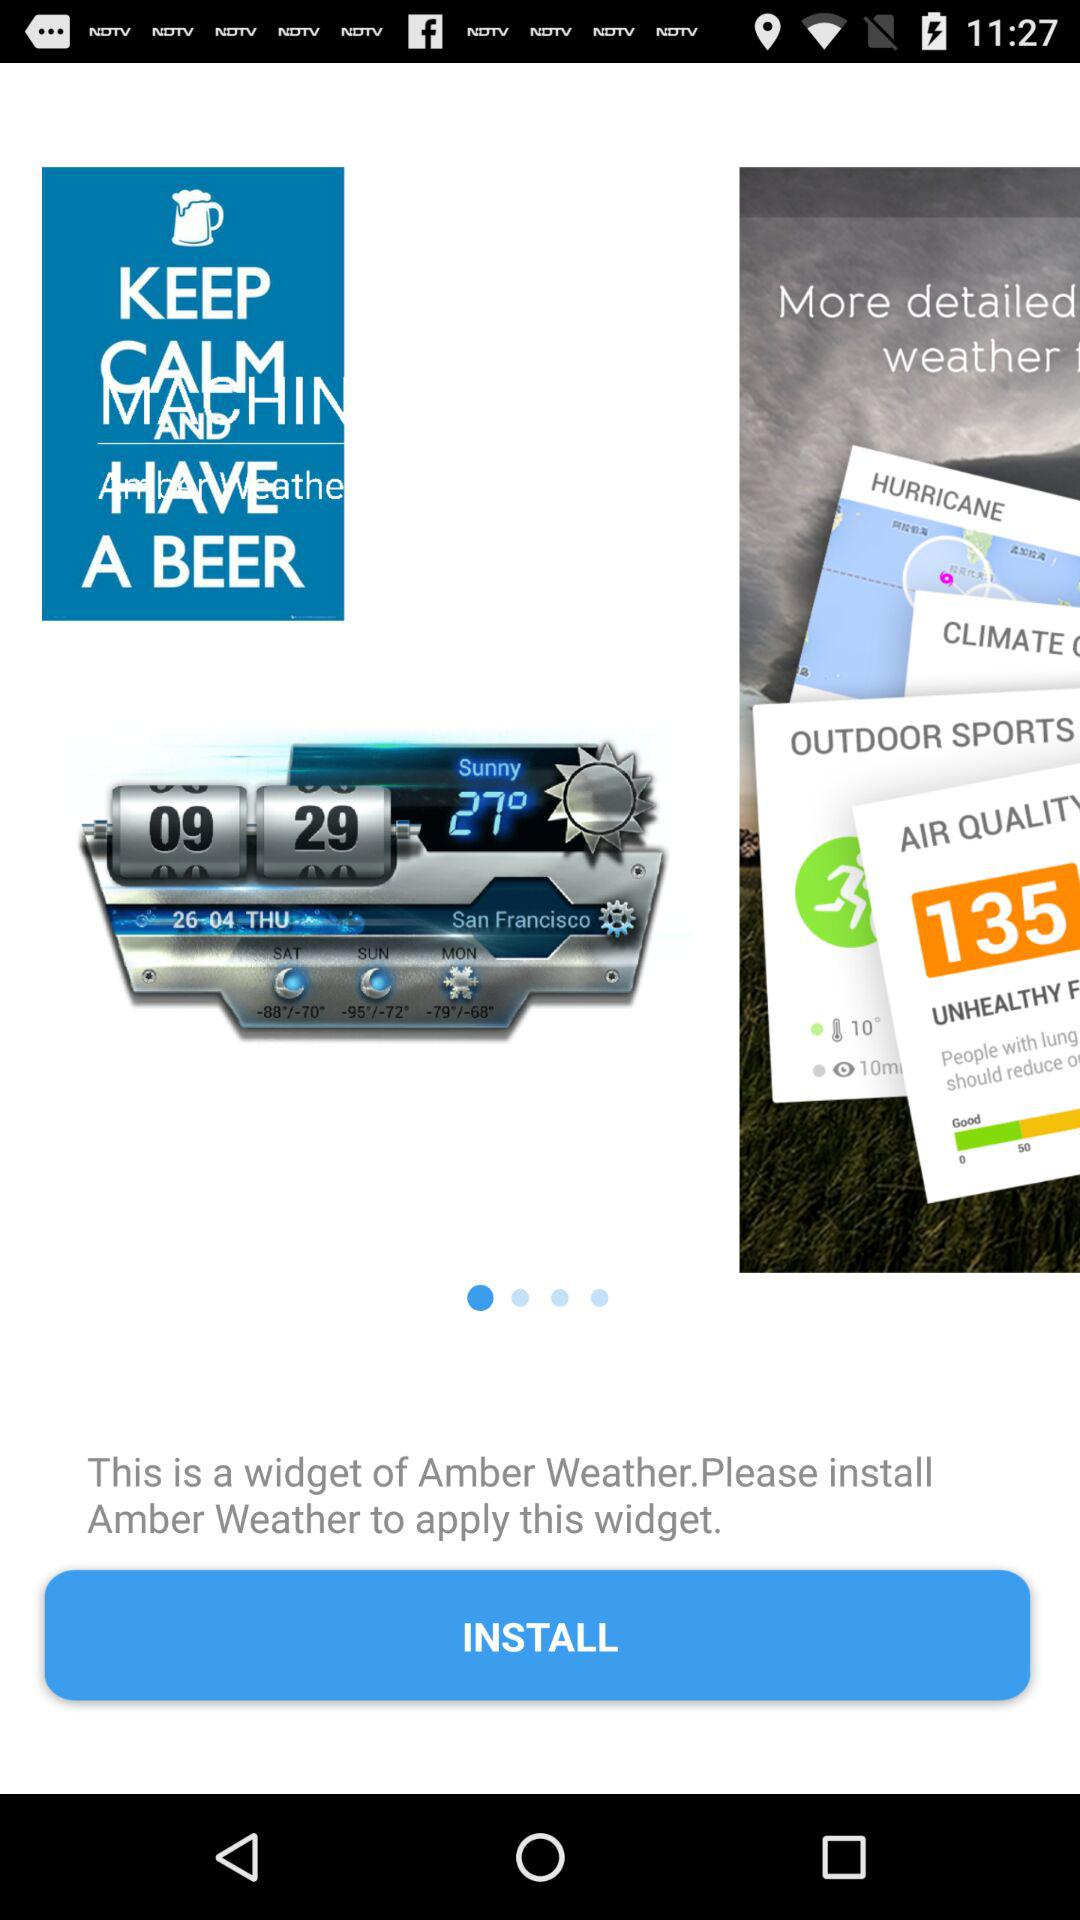What is the temperature on Monday? The temperature is -79° to -68° on Monday. 